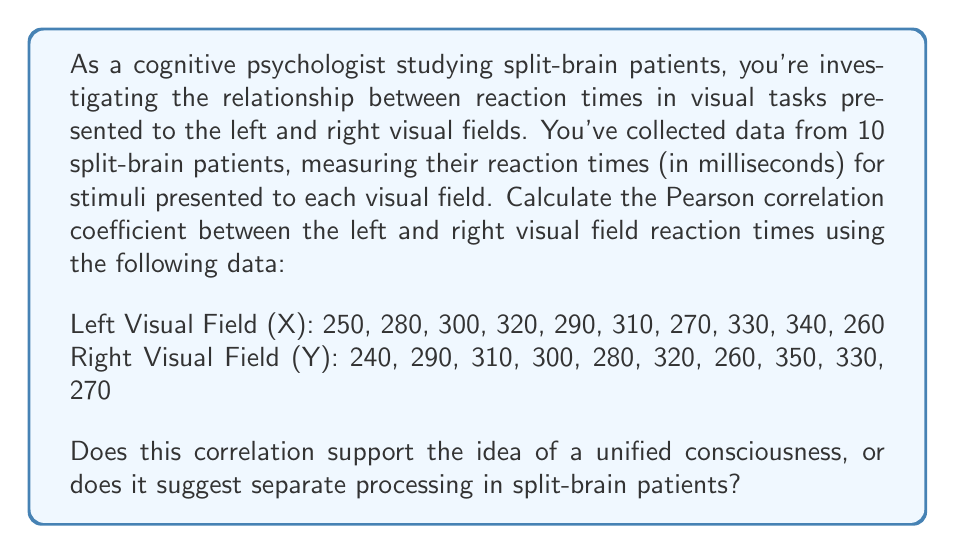Give your solution to this math problem. To calculate the Pearson correlation coefficient (r) between the left and right visual field reaction times, we'll follow these steps:

1. Calculate the means of X and Y:
   $$\bar{X} = \frac{\sum X}{n} = \frac{2950}{10} = 295$$
   $$\bar{Y} = \frac{\sum Y}{n} = \frac{2950}{10} = 295$$

2. Calculate the deviations from the mean for each X and Y value:
   $$(X - \bar{X}) \text{ and } (Y - \bar{Y})$$

3. Calculate the products of these deviations:
   $$(X - \bar{X})(Y - \bar{Y})$$

4. Sum these products:
   $$\sum(X - \bar{X})(Y - \bar{Y}) = 8100$$

5. Calculate the sum of squared deviations for X and Y:
   $$\sum(X - \bar{X})^2 = 9700$$
   $$\sum(Y - \bar{Y})^2 = 9700$$

6. Apply the formula for the Pearson correlation coefficient:
   $$r = \frac{\sum(X - \bar{X})(Y - \bar{Y})}{\sqrt{\sum(X - \bar{X})^2 \sum(Y - \bar{Y})^2}}$$

   $$r = \frac{8100}{\sqrt{9700 \cdot 9700}} = \frac{8100}{9700} \approx 0.8351$$

The correlation coefficient of approximately 0.8351 indicates a strong positive correlation between the reaction times in the left and right visual fields for these split-brain patients.

Interpreting this result in the context of consciousness:
This strong correlation suggests that despite the severed corpus callosum in split-brain patients, there is still a significant relationship between processing speeds in the two hemispheres. This could be due to shared subcortical pathways or similar cognitive strategies employed by each hemisphere. However, it doesn't necessarily support the idea of a unified consciousness, as the correlation is not perfect (r ≠ 1). The remaining unexplained variance could be attributed to the separate processing capabilities of each hemisphere in split-brain patients.

This result challenges the concept of consciousness as a completely unified entity, aligning with the perspective of a cognitive psychologist who questions this notion. It suggests that while there are shared aspects of cognitive processing between the hemispheres, there is also evidence for some level of independent functioning.
Answer: The Pearson correlation coefficient between the left and right visual field reaction times is approximately 0.8351, indicating a strong positive correlation. This result suggests shared processing mechanisms between hemispheres in split-brain patients, but also leaves room for some independent functioning, challenging the concept of a completely unified consciousness. 